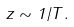Convert formula to latex. <formula><loc_0><loc_0><loc_500><loc_500>z \sim 1 / T .</formula> 